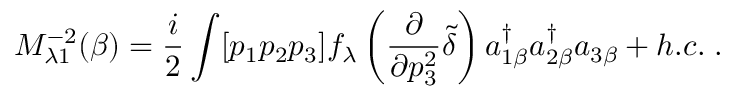Convert formula to latex. <formula><loc_0><loc_0><loc_500><loc_500>M _ { \lambda 1 } ^ { - 2 } ( \beta ) = \frac { i } { 2 } \int [ p _ { 1 } p _ { 2 } p _ { 3 } ] f _ { \lambda } \left ( \frac { \partial } { \partial p _ { 3 } ^ { 2 } } \tilde { \delta } \right ) a _ { 1 \beta } ^ { \dagger } a _ { 2 \beta } ^ { \dagger } a _ { 3 \beta } + h . c . \, .</formula> 